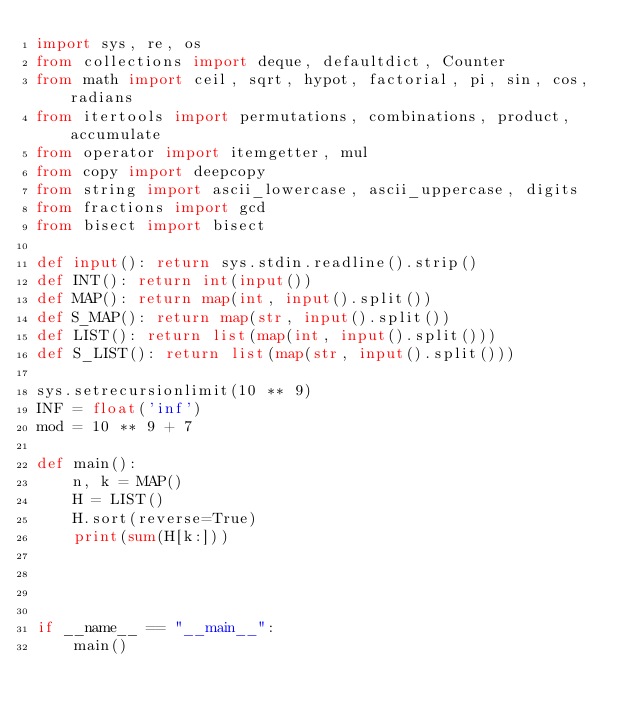Convert code to text. <code><loc_0><loc_0><loc_500><loc_500><_Python_>import sys, re, os
from collections import deque, defaultdict, Counter
from math import ceil, sqrt, hypot, factorial, pi, sin, cos, radians
from itertools import permutations, combinations, product, accumulate
from operator import itemgetter, mul
from copy import deepcopy
from string import ascii_lowercase, ascii_uppercase, digits
from fractions import gcd
from bisect import bisect
 
def input(): return sys.stdin.readline().strip()
def INT(): return int(input())
def MAP(): return map(int, input().split())
def S_MAP(): return map(str, input().split())
def LIST(): return list(map(int, input().split()))
def S_LIST(): return list(map(str, input().split()))
 
sys.setrecursionlimit(10 ** 9)
INF = float('inf')
mod = 10 ** 9 + 7

def main():
    n, k = MAP()
    H = LIST()
    H.sort(reverse=True)
    print(sum(H[k:]))




if __name__ == "__main__":
    main()</code> 